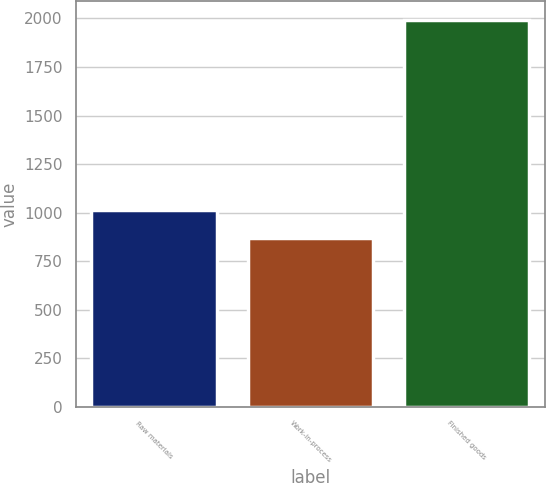Convert chart to OTSL. <chart><loc_0><loc_0><loc_500><loc_500><bar_chart><fcel>Raw materials<fcel>Work-in-process<fcel>Finished goods<nl><fcel>1016<fcel>871<fcel>1990<nl></chart> 